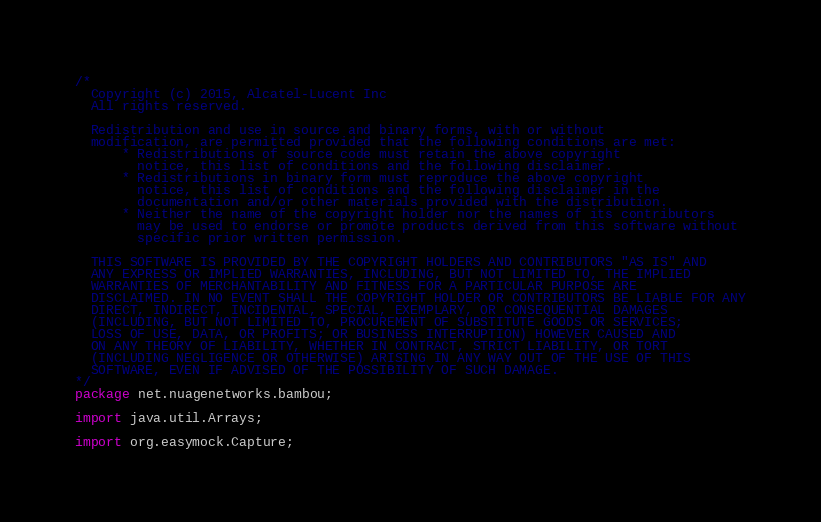<code> <loc_0><loc_0><loc_500><loc_500><_Java_>/*
  Copyright (c) 2015, Alcatel-Lucent Inc
  All rights reserved.

  Redistribution and use in source and binary forms, with or without
  modification, are permitted provided that the following conditions are met:
      * Redistributions of source code must retain the above copyright
        notice, this list of conditions and the following disclaimer.
      * Redistributions in binary form must reproduce the above copyright
        notice, this list of conditions and the following disclaimer in the
        documentation and/or other materials provided with the distribution.
      * Neither the name of the copyright holder nor the names of its contributors
        may be used to endorse or promote products derived from this software without
        specific prior written permission.

  THIS SOFTWARE IS PROVIDED BY THE COPYRIGHT HOLDERS AND CONTRIBUTORS "AS IS" AND
  ANY EXPRESS OR IMPLIED WARRANTIES, INCLUDING, BUT NOT LIMITED TO, THE IMPLIED
  WARRANTIES OF MERCHANTABILITY AND FITNESS FOR A PARTICULAR PURPOSE ARE
  DISCLAIMED. IN NO EVENT SHALL THE COPYRIGHT HOLDER OR CONTRIBUTORS BE LIABLE FOR ANY
  DIRECT, INDIRECT, INCIDENTAL, SPECIAL, EXEMPLARY, OR CONSEQUENTIAL DAMAGES
  (INCLUDING, BUT NOT LIMITED TO, PROCUREMENT OF SUBSTITUTE GOODS OR SERVICES;
  LOSS OF USE, DATA, OR PROFITS; OR BUSINESS INTERRUPTION) HOWEVER CAUSED AND
  ON ANY THEORY OF LIABILITY, WHETHER IN CONTRACT, STRICT LIABILITY, OR TORT
  (INCLUDING NEGLIGENCE OR OTHERWISE) ARISING IN ANY WAY OUT OF THE USE OF THIS
  SOFTWARE, EVEN IF ADVISED OF THE POSSIBILITY OF SUCH DAMAGE.
*/
package net.nuagenetworks.bambou;

import java.util.Arrays;

import org.easymock.Capture;</code> 